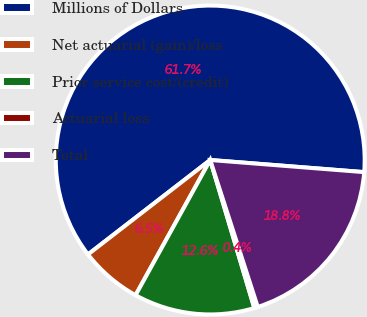Convert chart. <chart><loc_0><loc_0><loc_500><loc_500><pie_chart><fcel>Millions of Dollars<fcel>Net actuarial (gain)/loss<fcel>Prior service cost/(credit)<fcel>Actuarial loss<fcel>Total<nl><fcel>61.72%<fcel>6.5%<fcel>12.64%<fcel>0.37%<fcel>18.77%<nl></chart> 